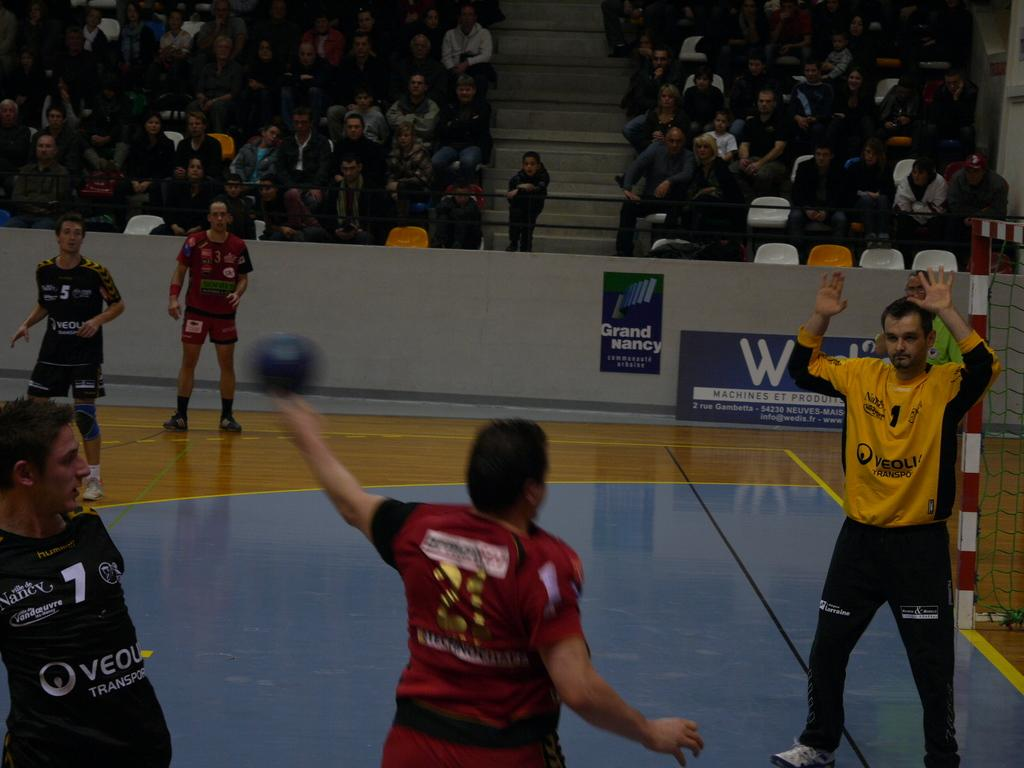<image>
Present a compact description of the photo's key features. The goalie attempts to stop a shot thrown by number 21. 